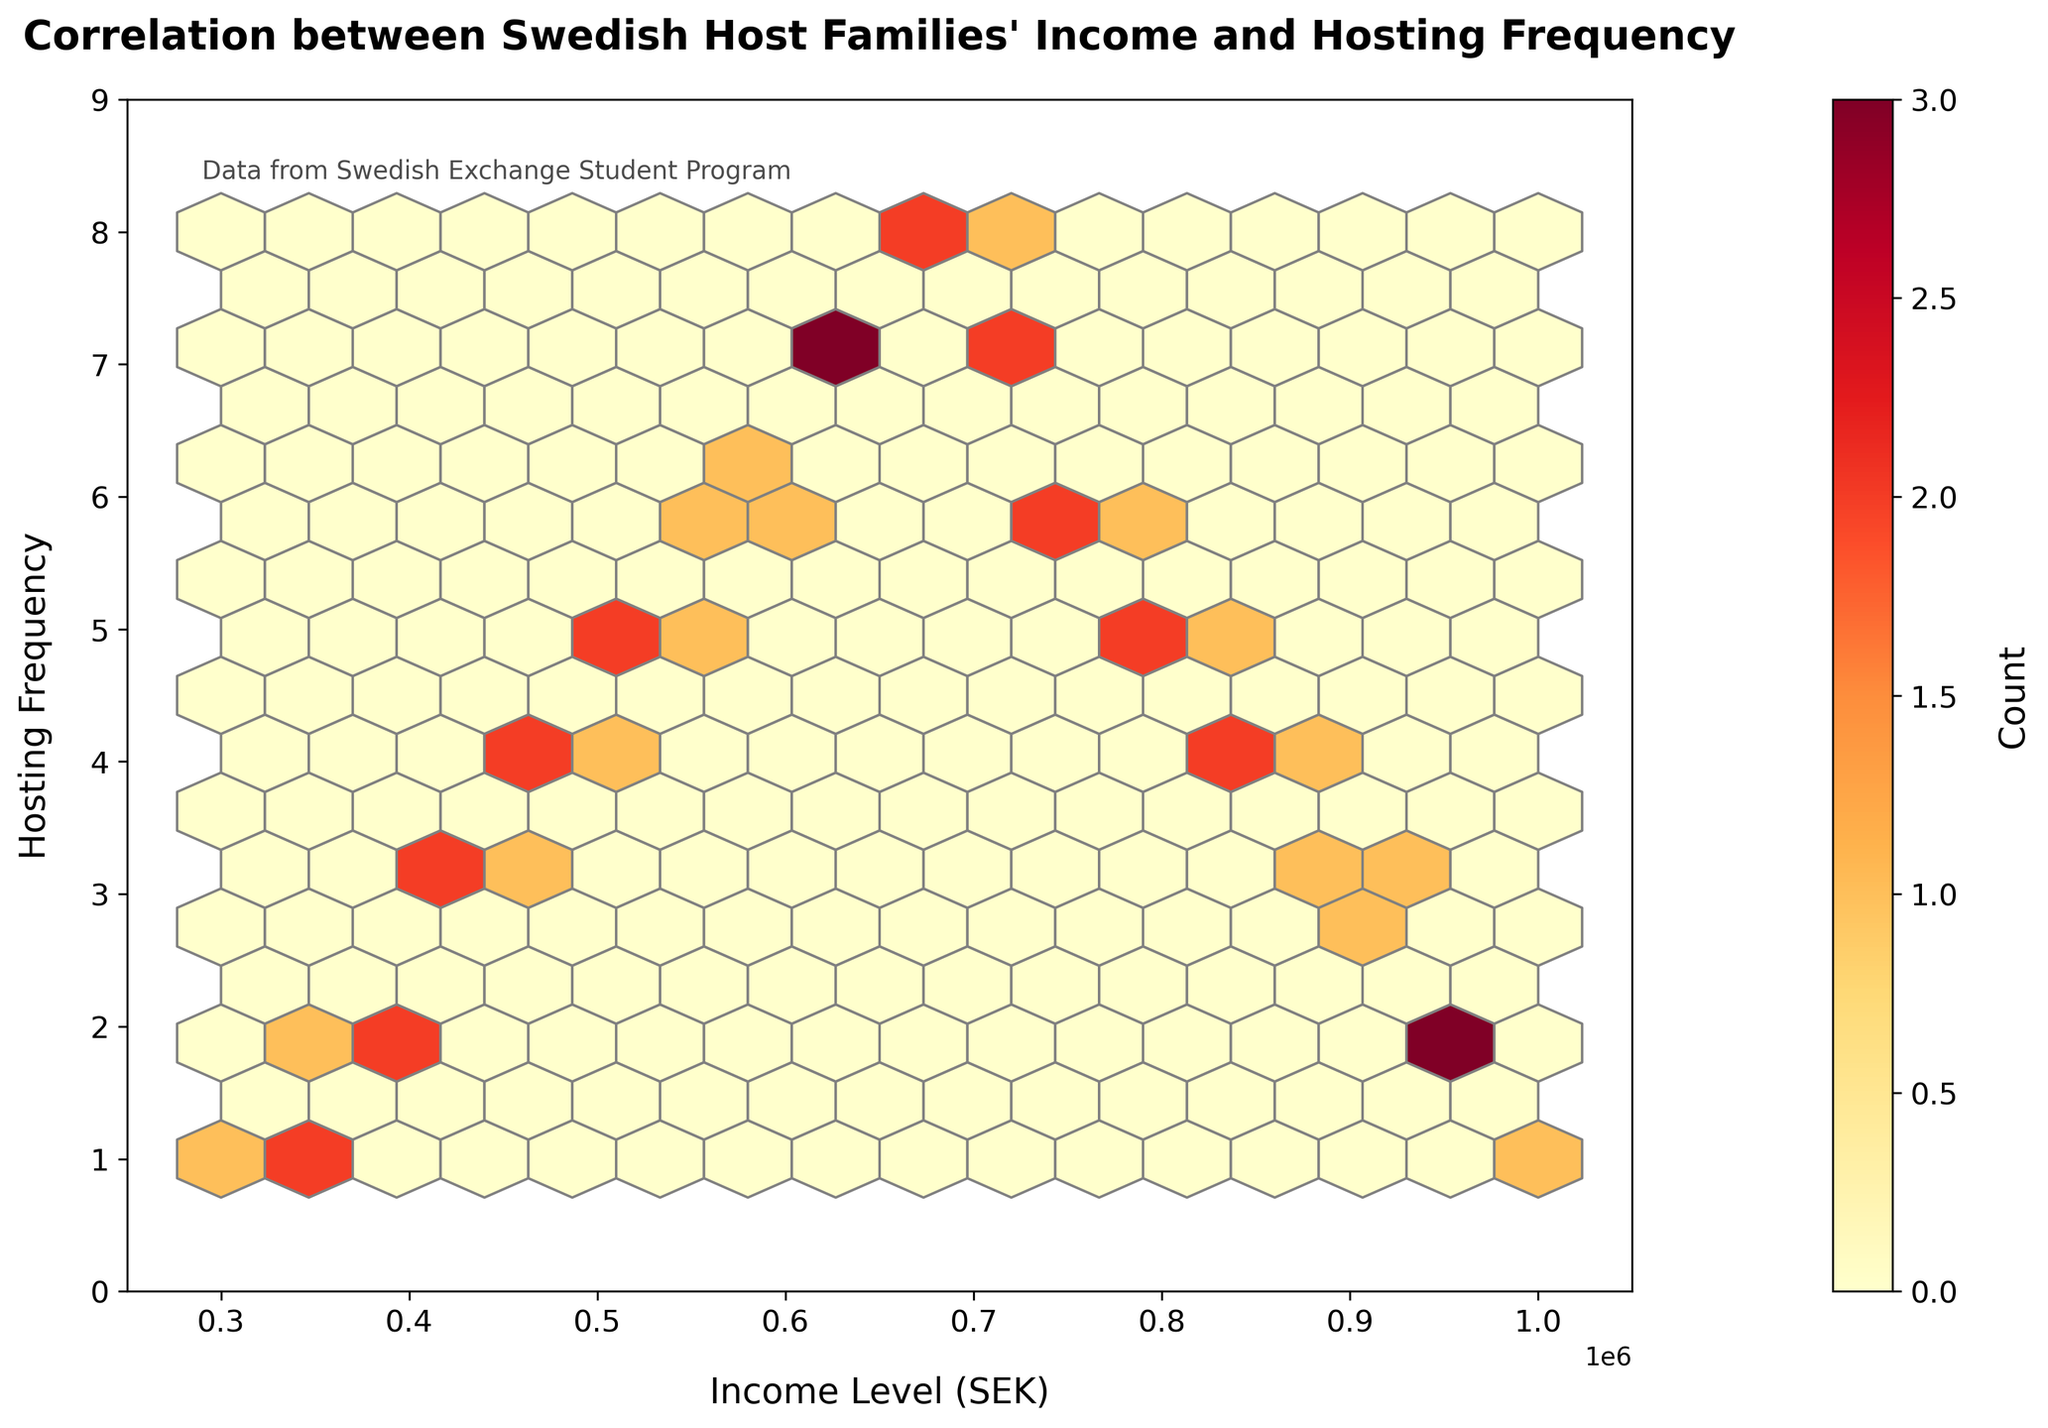What is the title of the plot? The title is located at the top of the plot and is "Correlation between Swedish Host Families' Income and Hosting Frequency"
Answer: Correlation between Swedish Host Families' Income and Hosting Frequency What are the ranges of the income levels and hosting frequencies shown in the plot? The ranges can be identified by looking at the axes limits; the x-axis (Income Level) ranges from 250,000 SEK to 1,050,000 SEK, and the y-axis (Hosting Frequency) ranges from 0 to 9
Answer: Income Level: 250,000 SEK to 1,050,000 SEK, Hosting Frequency: 0 to 9 Which hosting frequency appears to have the highest concentration of data points? This can be identified by the hexbin with the highest color intensity, which represents a higher count in that bin. The frequency with the highest concentration is 6
Answer: 6 Which income level has the highest frequency of 8 for hosting exchange students? Refer to the hexbin plot to find the bin closest to y = 8 with a higher density of data points by color intensity. This highest concentration appears near income level 700,000 SEK
Answer: 700,000 SEK What color represents the highest count in the hexbin plot? In a hexbin plot, the color intensity usually represents the density of the data points. By looking at the color bar, the highest count corresponds to the darkest color present, which in this case is dark red
Answer: Dark red How does the frequency of hosting exchange students generally change with increasing income levels? Observe the trend in the plot from left to right. There is an increase in hosting frequency up to a certain income level (around 700,000 SEK), after which the frequency appears to decline
Answer: Generally increases then decreases At approximately what income level does hosting frequency start to decline after peaking? Locate the income level at the peak of hosting frequency (8) from the plot, after which it begins to decline. This occurs at around 700,000 SEK
Answer: 700,000 SEK What information is provided by the color bar in the plot? The color bar represents the count of how many data points fall into each hexbin, helping to visualize data density. The label "Count" and the colors ranging from light to dark indicate this information
Answer: Count of data points in each hexbin How many host families have an income level between 400,000 SEK and 600,000 SEK and a hosting frequency of 6? Count the hexagons within the specified income range on the x-axis that align with the y-value of 6 on the plotting area. This appears to be close to 2 hexagons
Answer: Approximately 2 hexagons What does the hexbin plot suggest about the correlation between income level and hosting frequency? The plot shows a trend of initial increase in hosting frequency with increasing income levels up to a peak, followed by a decline; suggesting a non-linear relationship
Answer: Non-linear relationship 